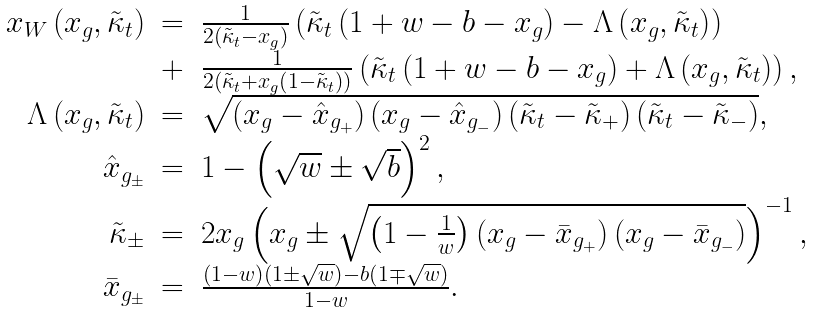<formula> <loc_0><loc_0><loc_500><loc_500>\begin{array} { r c l } x _ { W } \left ( x _ { g } , \tilde { \kappa } _ { t } \right ) & = & \frac { 1 } { 2 \left ( \tilde { \kappa } _ { t } - x _ { g } \right ) } \left ( \tilde { \kappa } _ { t } \left ( 1 + w - b - x _ { g } \right ) - \Lambda \left ( x _ { g } , \tilde { \kappa } _ { t } \right ) \right ) \\ & + & \frac { 1 } { 2 \left ( \tilde { \kappa } _ { t } + x _ { g } \left ( 1 - \tilde { \kappa } _ { t } \right ) \right ) } \left ( \tilde { \kappa } _ { t } \left ( 1 + w - b - x _ { g } \right ) + \Lambda \left ( x _ { g } , \tilde { \kappa } _ { t } \right ) \right ) , \\ \Lambda \left ( x _ { g } , \tilde { \kappa } _ { t } \right ) & = & \sqrt { \left ( x _ { g } - \hat { x } _ { g _ { + } } \right ) \left ( x _ { g } - \hat { x } _ { g _ { - } } \right ) \left ( \tilde { \kappa } _ { t } - \tilde { \kappa } _ { + } \right ) \left ( \tilde { \kappa } _ { t } - \tilde { \kappa } _ { - } \right ) } , \\ \hat { x } _ { g _ { \pm } } & = & 1 - \left ( \sqrt { w } \pm \sqrt { b } \right ) ^ { 2 } , \\ \tilde { \kappa } _ { \pm } & = & 2 x _ { g } \left ( x _ { g } \pm \sqrt { \left ( 1 - \frac { 1 } { w } \right ) \left ( x _ { g } - \bar { x } _ { g _ { + } } \right ) \left ( x _ { g } - \bar { x } _ { g _ { - } } \right ) } \right ) ^ { - 1 } , \\ \bar { x } _ { g _ { \pm } } & = & \frac { \left ( 1 - w \right ) \left ( 1 \pm \sqrt { w } \right ) - b \left ( 1 \mp \sqrt { w } \right ) } { 1 - w } . \end{array}</formula> 